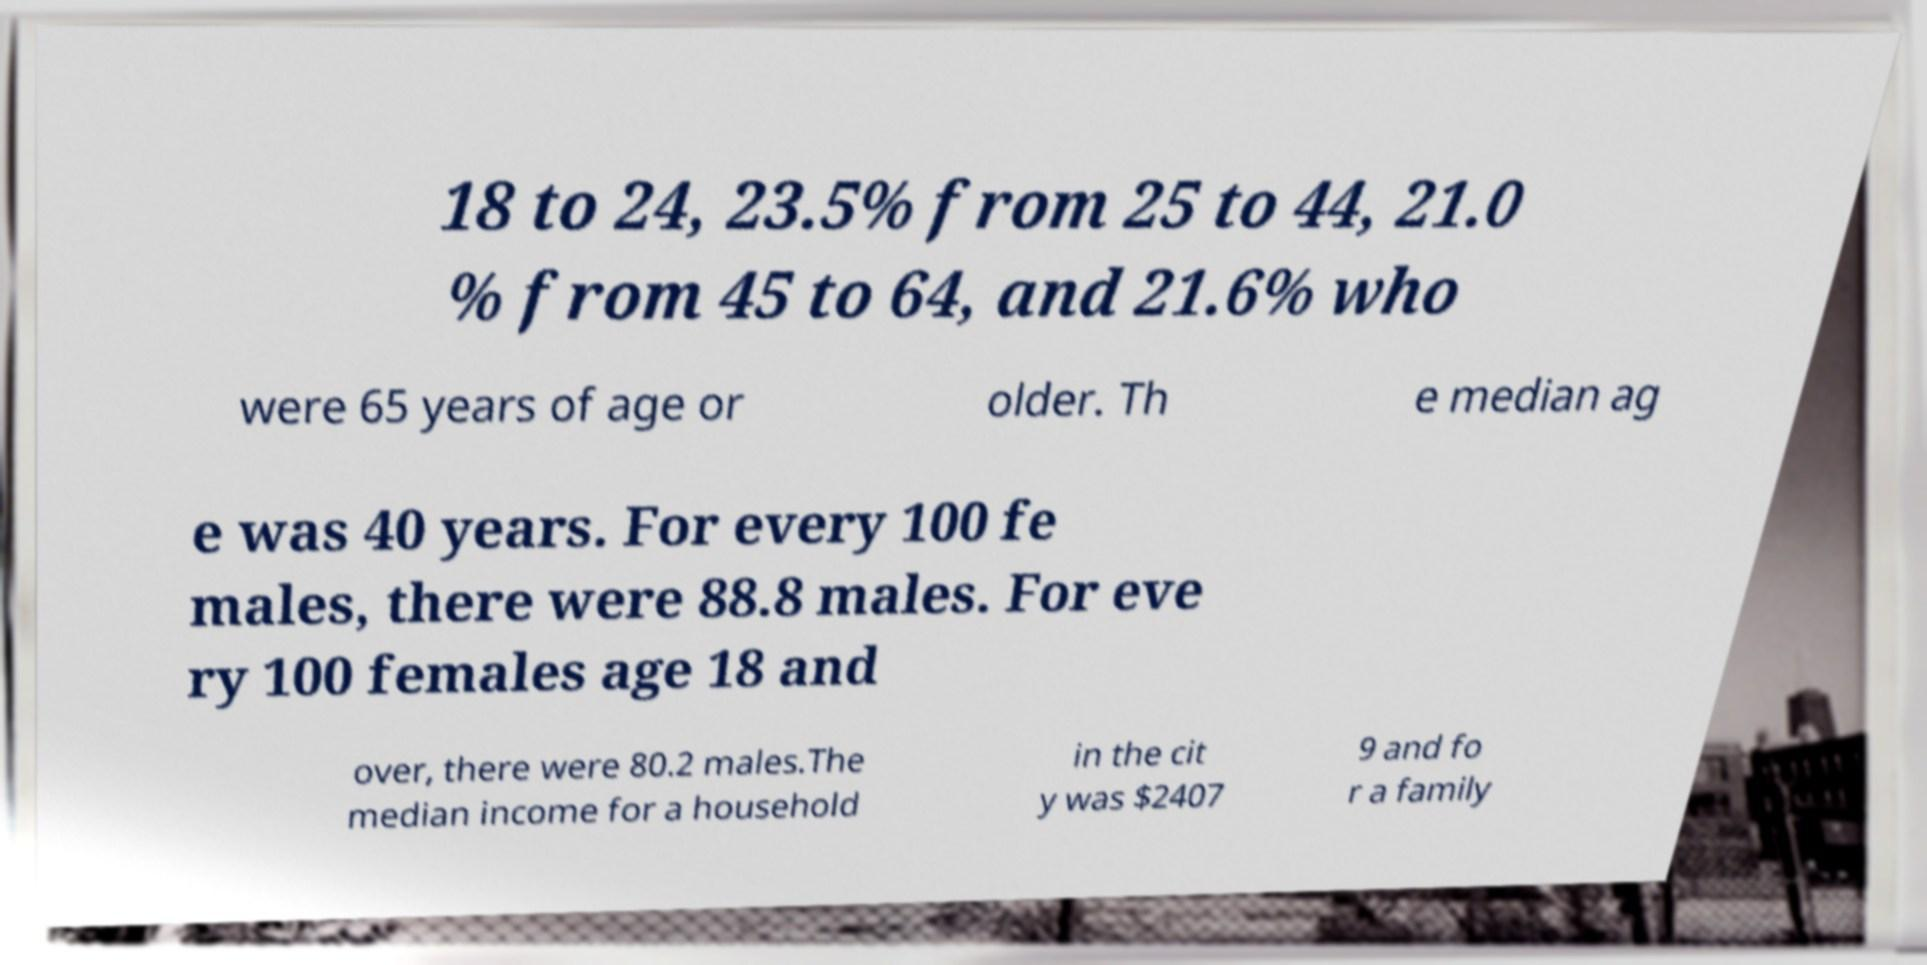Could you assist in decoding the text presented in this image and type it out clearly? 18 to 24, 23.5% from 25 to 44, 21.0 % from 45 to 64, and 21.6% who were 65 years of age or older. Th e median ag e was 40 years. For every 100 fe males, there were 88.8 males. For eve ry 100 females age 18 and over, there were 80.2 males.The median income for a household in the cit y was $2407 9 and fo r a family 